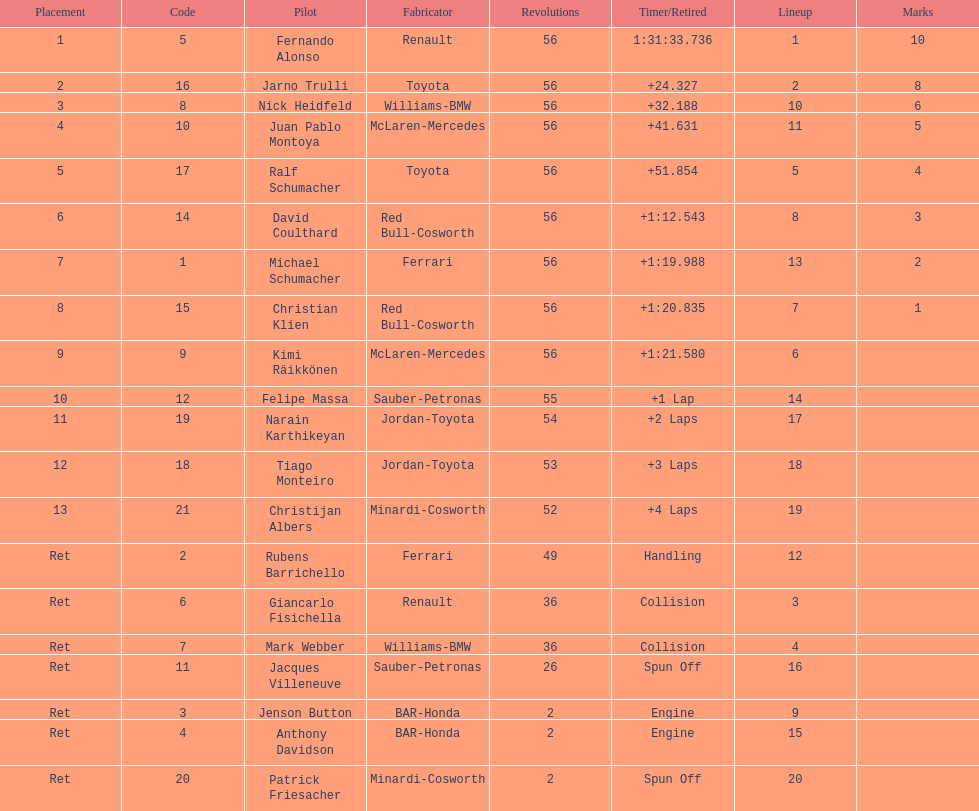Who was the last driver from the uk to actually finish the 56 laps? David Coulthard. 